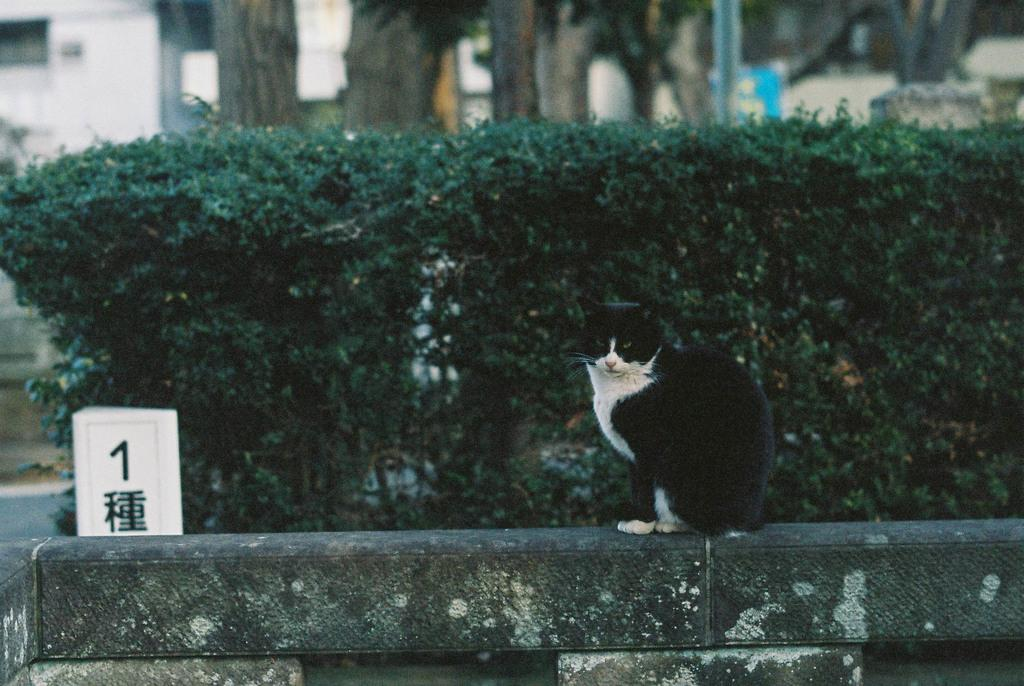What animal can be seen in the image? There is a cat in the image. Where is the cat located? The cat is on a slab. What can be seen in the background of the image? There are trees and buildings in the background of the image. Is there any text or number visible in the image? Yes, the number "1" is written on a pole in the image. What type of seed is the wren eating in the image? There is no wren or seed present in the image; it features a cat on a slab. How does the sail affect the cat's behavior in the image? There is no sail present in the image, so it cannot affect the cat's behavior. 